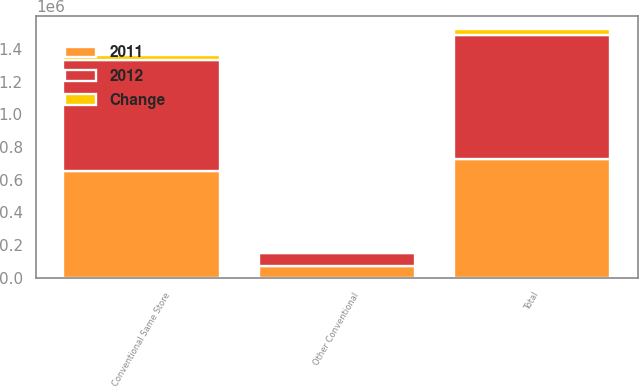Convert chart to OTSL. <chart><loc_0><loc_0><loc_500><loc_500><stacked_bar_chart><ecel><fcel>Conventional Same Store<fcel>Other Conventional<fcel>Total<nl><fcel>2012<fcel>681015<fcel>80861<fcel>761876<nl><fcel>2011<fcel>652058<fcel>72808<fcel>724866<nl><fcel>Change<fcel>28957<fcel>8053<fcel>37010<nl></chart> 